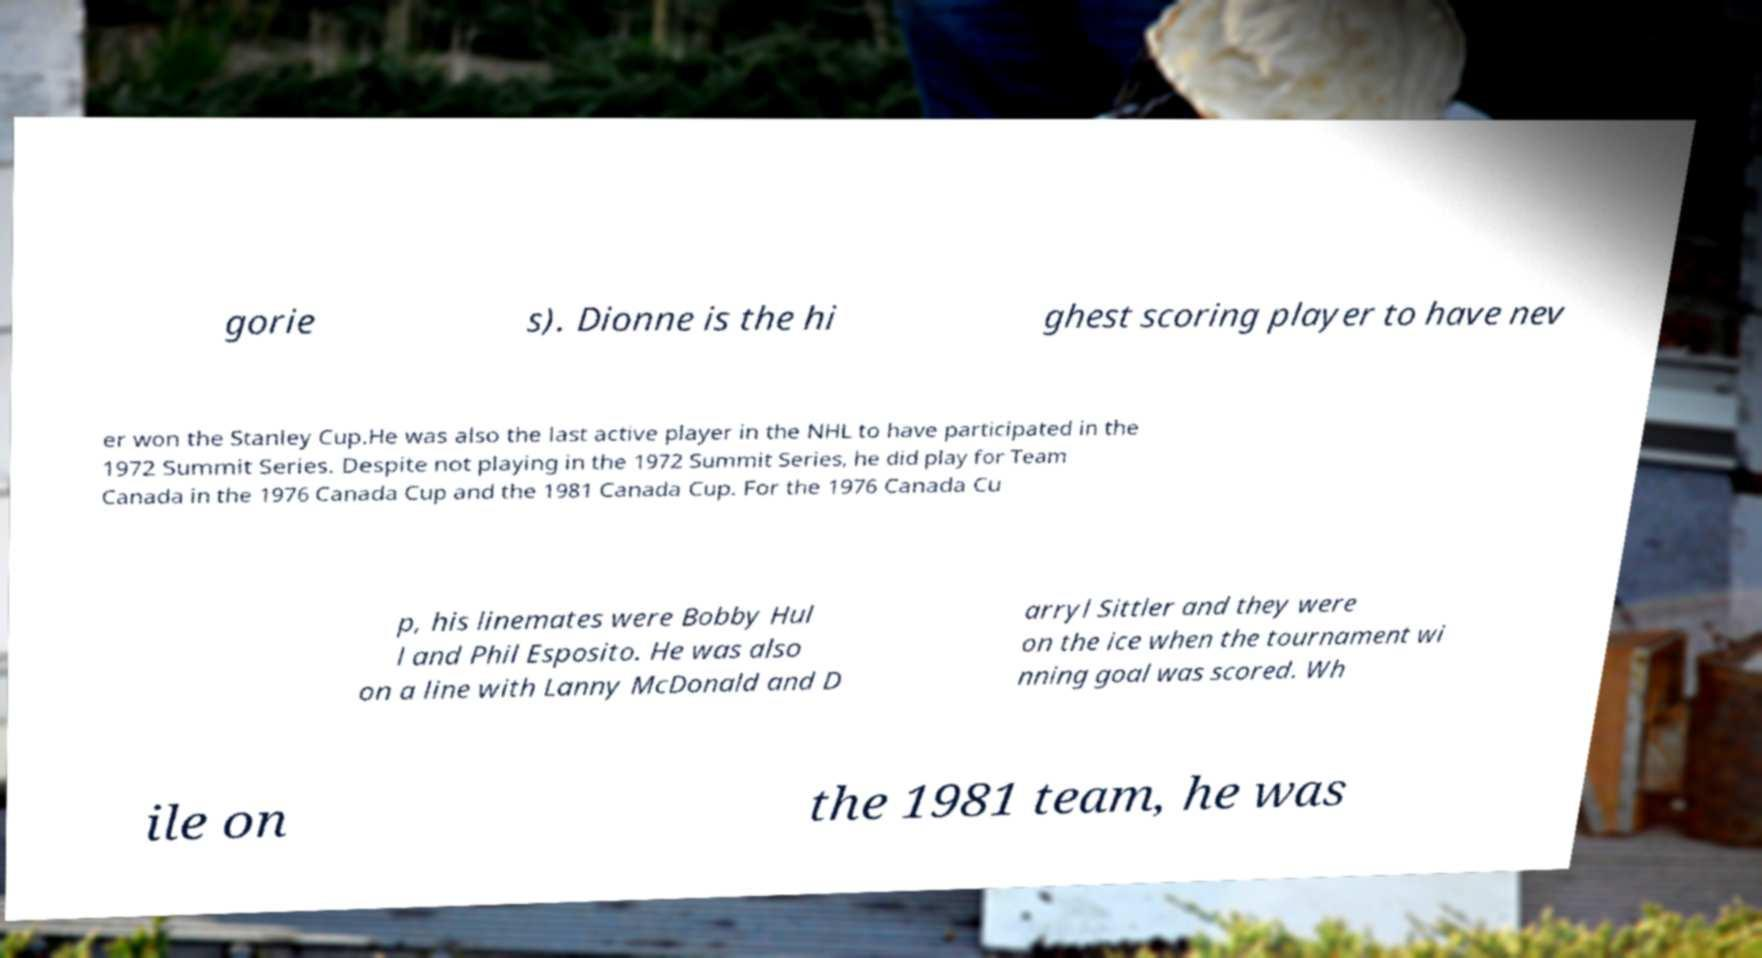I need the written content from this picture converted into text. Can you do that? gorie s). Dionne is the hi ghest scoring player to have nev er won the Stanley Cup.He was also the last active player in the NHL to have participated in the 1972 Summit Series. Despite not playing in the 1972 Summit Series, he did play for Team Canada in the 1976 Canada Cup and the 1981 Canada Cup. For the 1976 Canada Cu p, his linemates were Bobby Hul l and Phil Esposito. He was also on a line with Lanny McDonald and D arryl Sittler and they were on the ice when the tournament wi nning goal was scored. Wh ile on the 1981 team, he was 